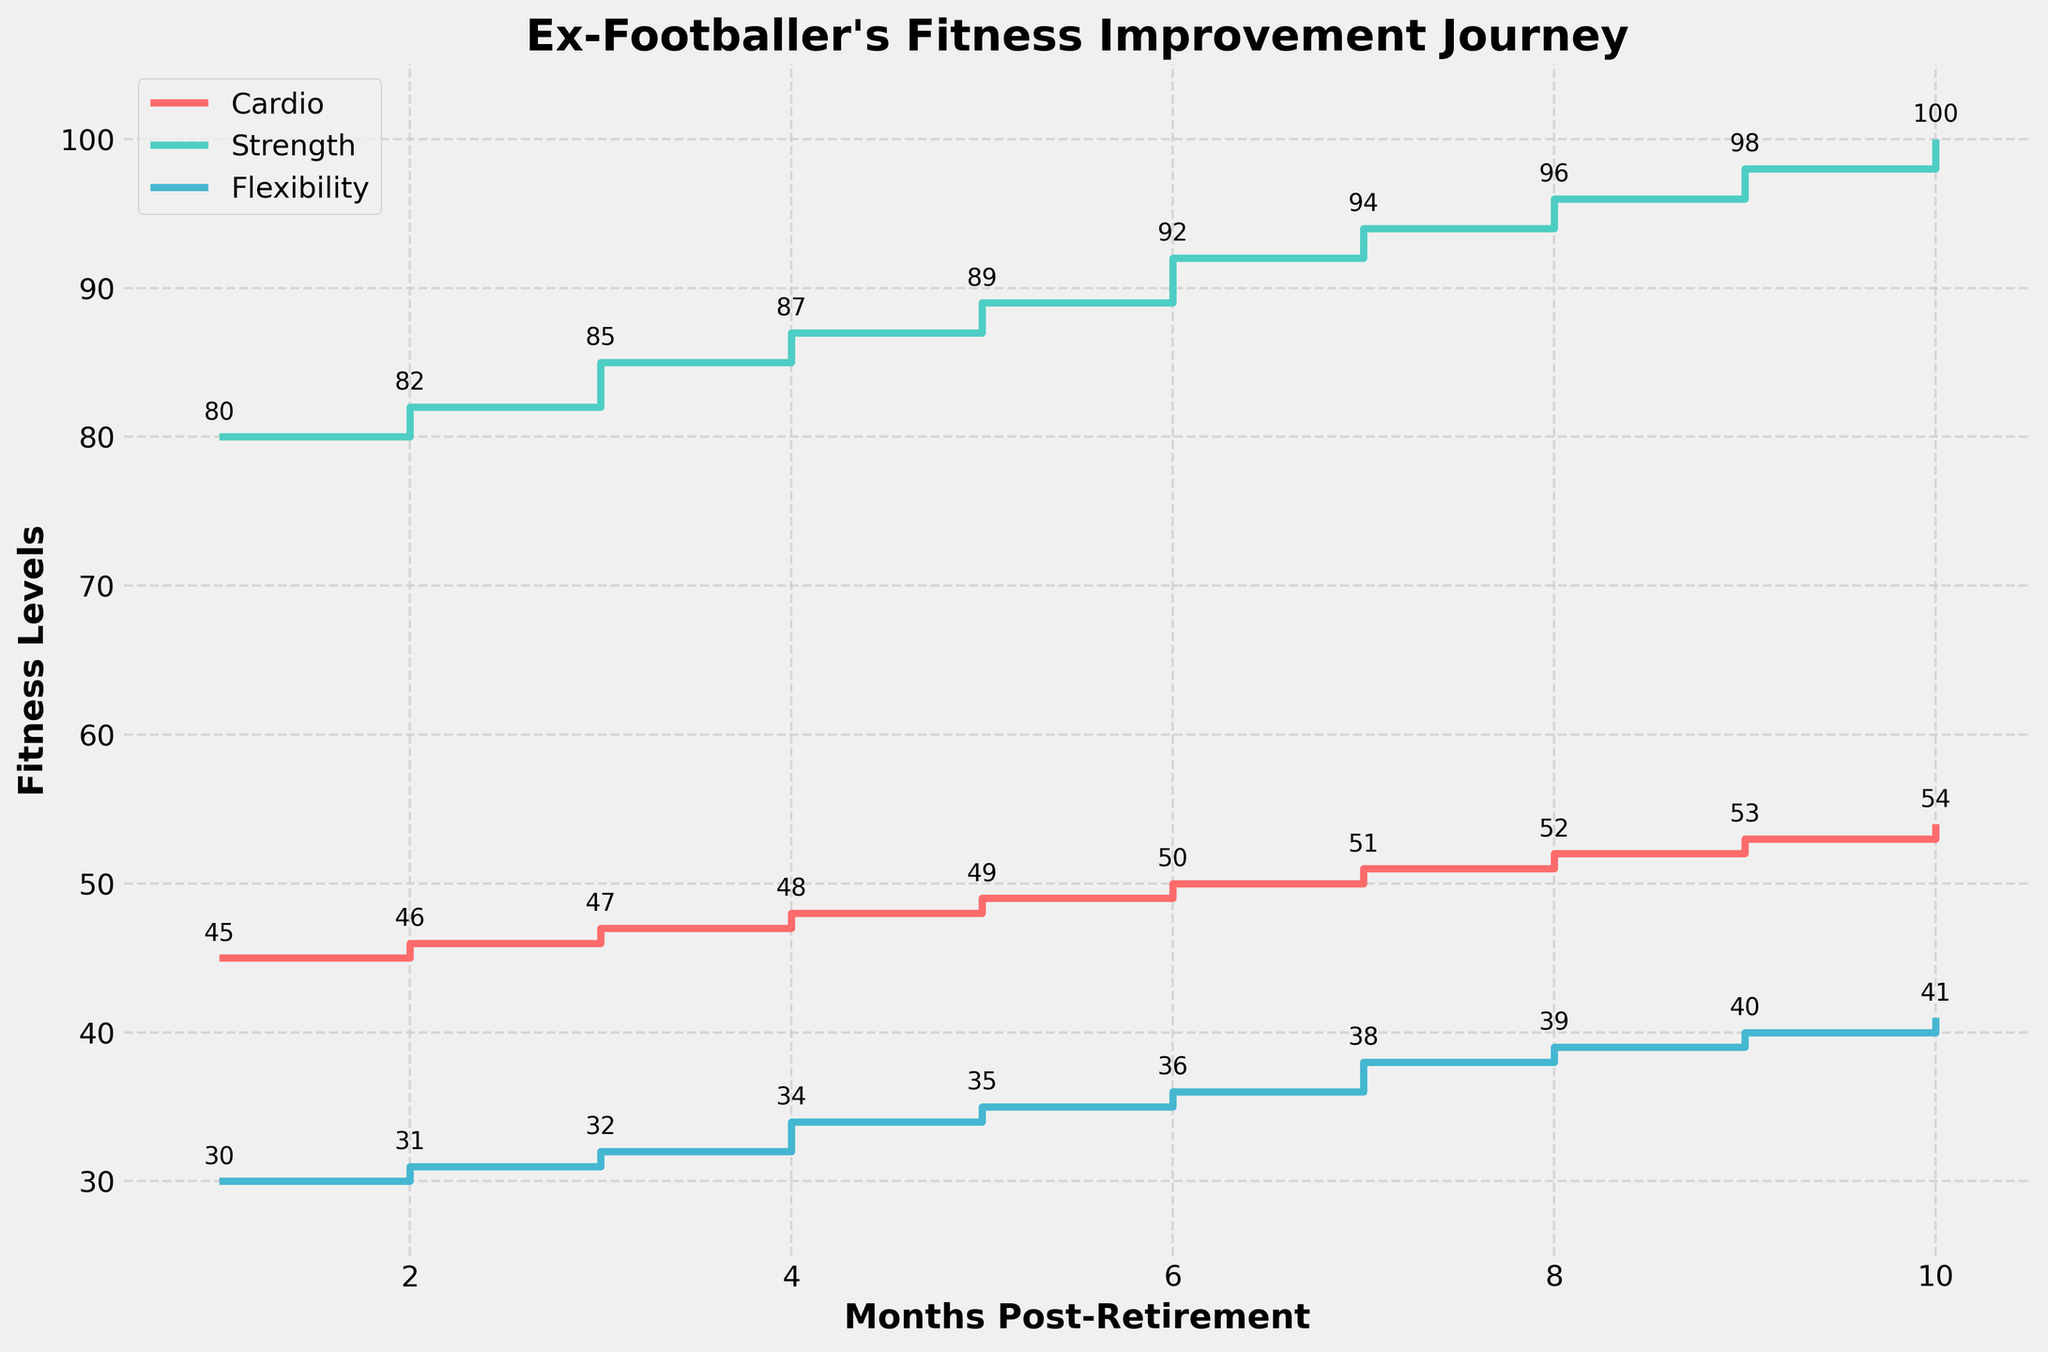What's the title of the figure? The title can be found at the top of the figure. It reads "Ex-Footballer's Fitness Improvement Journey."
Answer: Ex-Footballer's Fitness Improvement Journey What is the x-axis label? The x-axis label is placed horizontally at the bottom of the plot. It reads "Months Post-Retirement."
Answer: Months Post-Retirement How many total months are represented in the plot? The x-axis shows values from 1 to 10, indicating the number of months.
Answer: 10 What color is used to represent Flexibility? The color used for Flexibility is shown in the legend under the label "Flexibility" and also in the data line.
Answer: Blue What was the Strength Level (1RM Bench Press) at Month 5? Locate Month 5 on the x-axis and find the corresponding y-value for the Strength Level step line. The annotation also shows the value.
Answer: 89 What's the increase in Cardio Fitness Level (VO2 Max) from Month 1 to Month 10? The initial value at Month 1 is 45, and the final value at Month 10 is 54. The increase is calculated as 54 - 45.
Answer: 9 Which fitness metric showed the greatest improvement over 10 months? Compare the increases in Cardio Fitness Level (54-45), Strength Level (100-80), and Flexibility (41-30). The largest increase is in Strength Level by 20 units.
Answer: Strength Level How does the Flexibility value at Month 3 compare to that at Month 6? Find the Flexibility values at both months: 32 at Month 3 and 36 at Month 6. The difference is 36 - 32.
Answer: 4 units higher What was the average Cardio Fitness Level (VO2 Max) over the 10 months? Add all Cardio Fitness values: 45+46+47+48+49+50+51+52+53+54 and divide by 10.
Answer: 49.5 During which month did the Strength Level (1RM Bench Press) reach 94? Locate the y-value 94 on the Strength Level line and match it with the corresponding x-axis value.
Answer: Month 7 